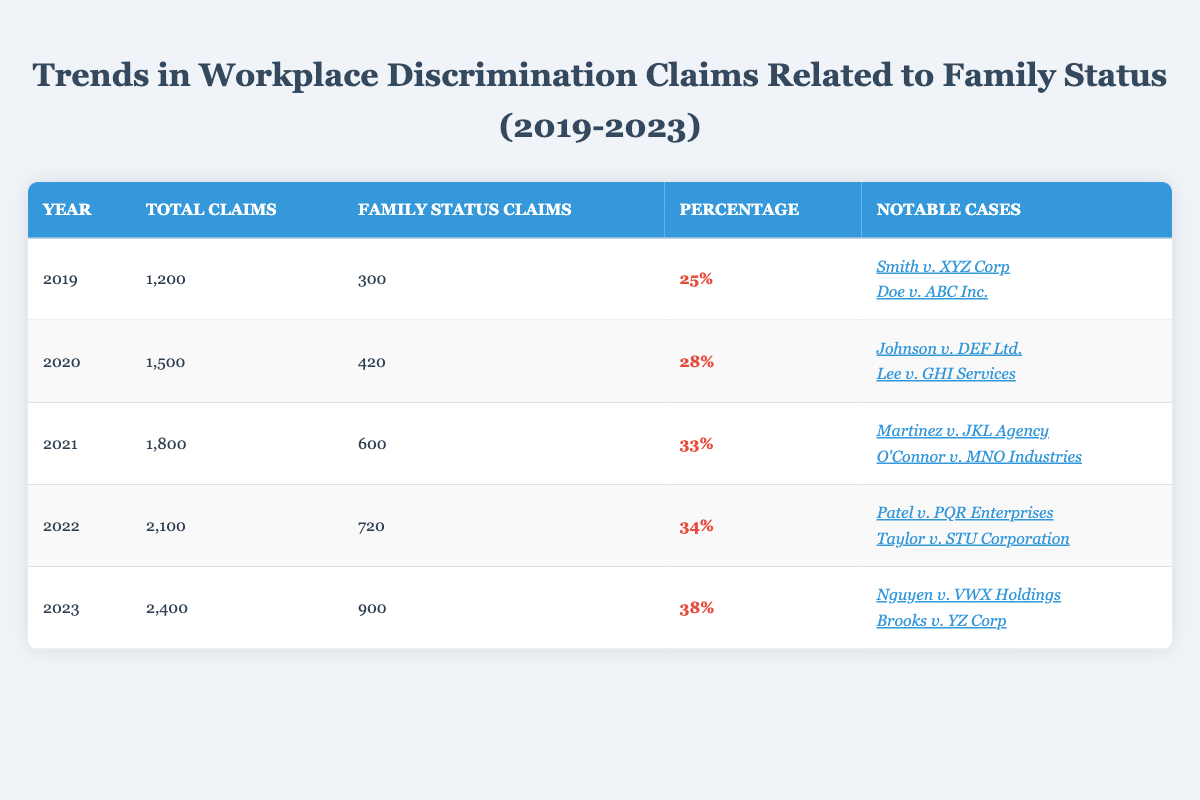What was the total number of workplace discrimination claims in 2022? In 2022, the table indicates that the total number of claims was listed as 2,100.
Answer: 2,100 How many family status claims were made in 2021? According to the table, in 2021, the number of family status claims was listed as 600.
Answer: 600 What percentage of total claims were related to family status in 2023? The table shows that in 2023, the percentage for family status claims was 38%.
Answer: 38% Which year had the highest number of family status claims? By examining the table, we can see that 2023 had the highest number of family status claims at 900.
Answer: 2023 What was the increase in total workplace discrimination claims from 2019 to 2023? The total claims in 2019 were 1,200, and in 2023, it was 2,400. The increase is calculated as 2,400 - 1,200 = 1,200.
Answer: 1,200 Did the percentage of family status claims ever exceed 30% during this period? Looking at the percentages, 2021 (33%), 2022 (34%), and 2023 (38%) all exceeded 30%.
Answer: Yes How many family status claims were filed in 2020 compared to 2022? In 2020, the family status claims were 420, and in 2022, they were 720. The difference is 720 - 420 = 300 more claims in 2022.
Answer: 300 Which notable case involved a settlement related to parental leave? The table indicates that "Johnson v. DEF Ltd." in Texas resulted in a trial verdict in favor of the plaintiff after being fired for requesting parental leave, while "Nguyen v. VWX Holdings" involved a settlement after discrimination for family emergencies, making it the case related to settlement and parental context.
Answer: Nguyen v. VWX Holdings What was the combined total of family status claims for the years 2020 and 2021? The family status claims for 2020 were 420, and for 2021, they were 600. Adding these gives 420 + 600 = 1,020.
Answer: 1,020 How did the percentage of family status claims change from 2019 to 2023? In 2019, the percentage was 25%, while in 2023, it rose to 38%. To find the change: 38% - 25% = 13%.
Answer: Increased by 13% 